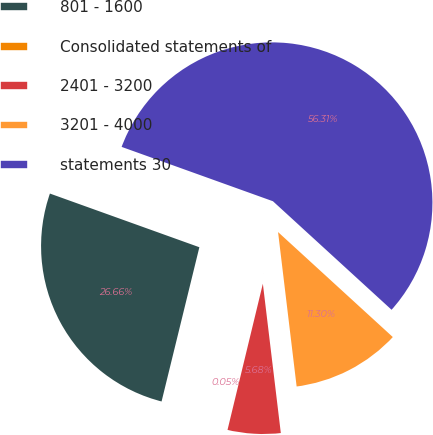Convert chart. <chart><loc_0><loc_0><loc_500><loc_500><pie_chart><fcel>801 - 1600<fcel>Consolidated statements of<fcel>2401 - 3200<fcel>3201 - 4000<fcel>statements 30<nl><fcel>26.66%<fcel>0.05%<fcel>5.68%<fcel>11.3%<fcel>56.3%<nl></chart> 